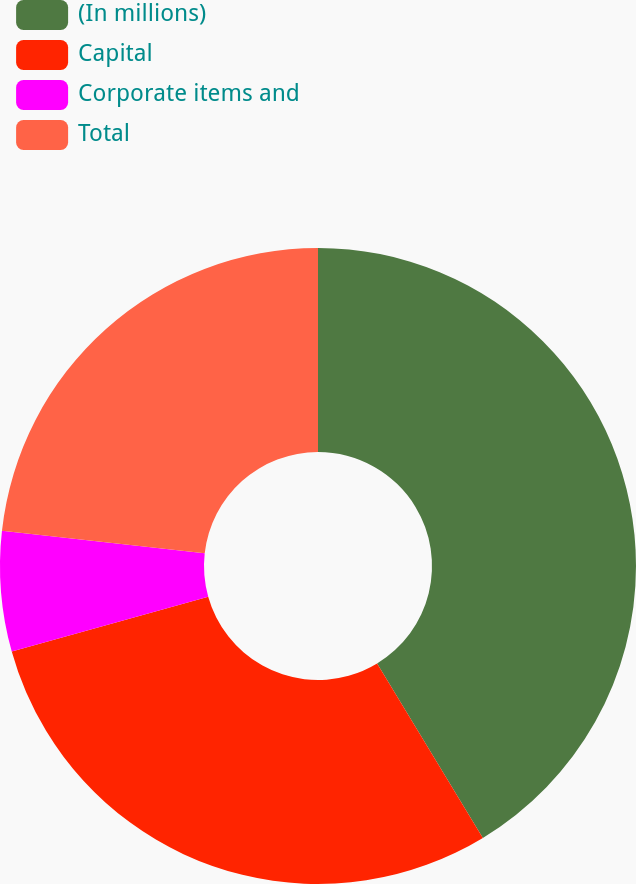<chart> <loc_0><loc_0><loc_500><loc_500><pie_chart><fcel>(In millions)<fcel>Capital<fcel>Corporate items and<fcel>Total<nl><fcel>41.33%<fcel>29.34%<fcel>6.11%<fcel>23.23%<nl></chart> 